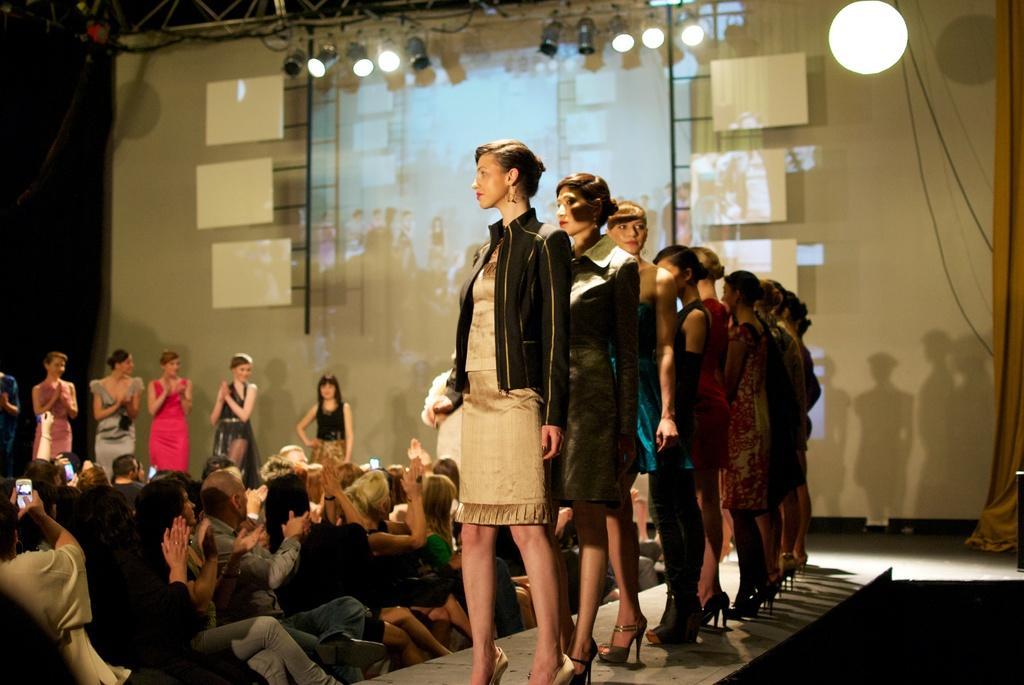Please provide a concise description of this image. In the image I can see some ladies who are standing on the ramp and around there are some other people sitting and also I can see some lights to the roof. 